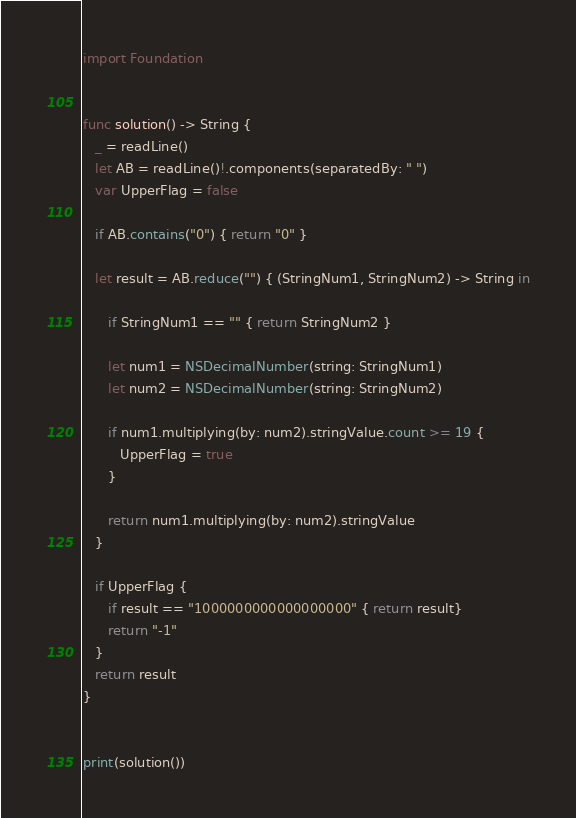<code> <loc_0><loc_0><loc_500><loc_500><_Swift_>import Foundation


func solution() -> String {
   _ = readLine()
   let AB = readLine()!.components(separatedBy: " ")
   var UpperFlag = false
   
   if AB.contains("0") { return "0" }
   
   let result = AB.reduce("") { (StringNum1, StringNum2) -> String in
      
      if StringNum1 == "" { return StringNum2 }
      
      let num1 = NSDecimalNumber(string: StringNum1)
      let num2 = NSDecimalNumber(string: StringNum2)
      
      if num1.multiplying(by: num2).stringValue.count >= 19 {
         UpperFlag = true
      }
      
      return num1.multiplying(by: num2).stringValue
   }
   
   if UpperFlag {
      if result == "1000000000000000000" { return result}
      return "-1"
   }
   return result
}


print(solution())</code> 